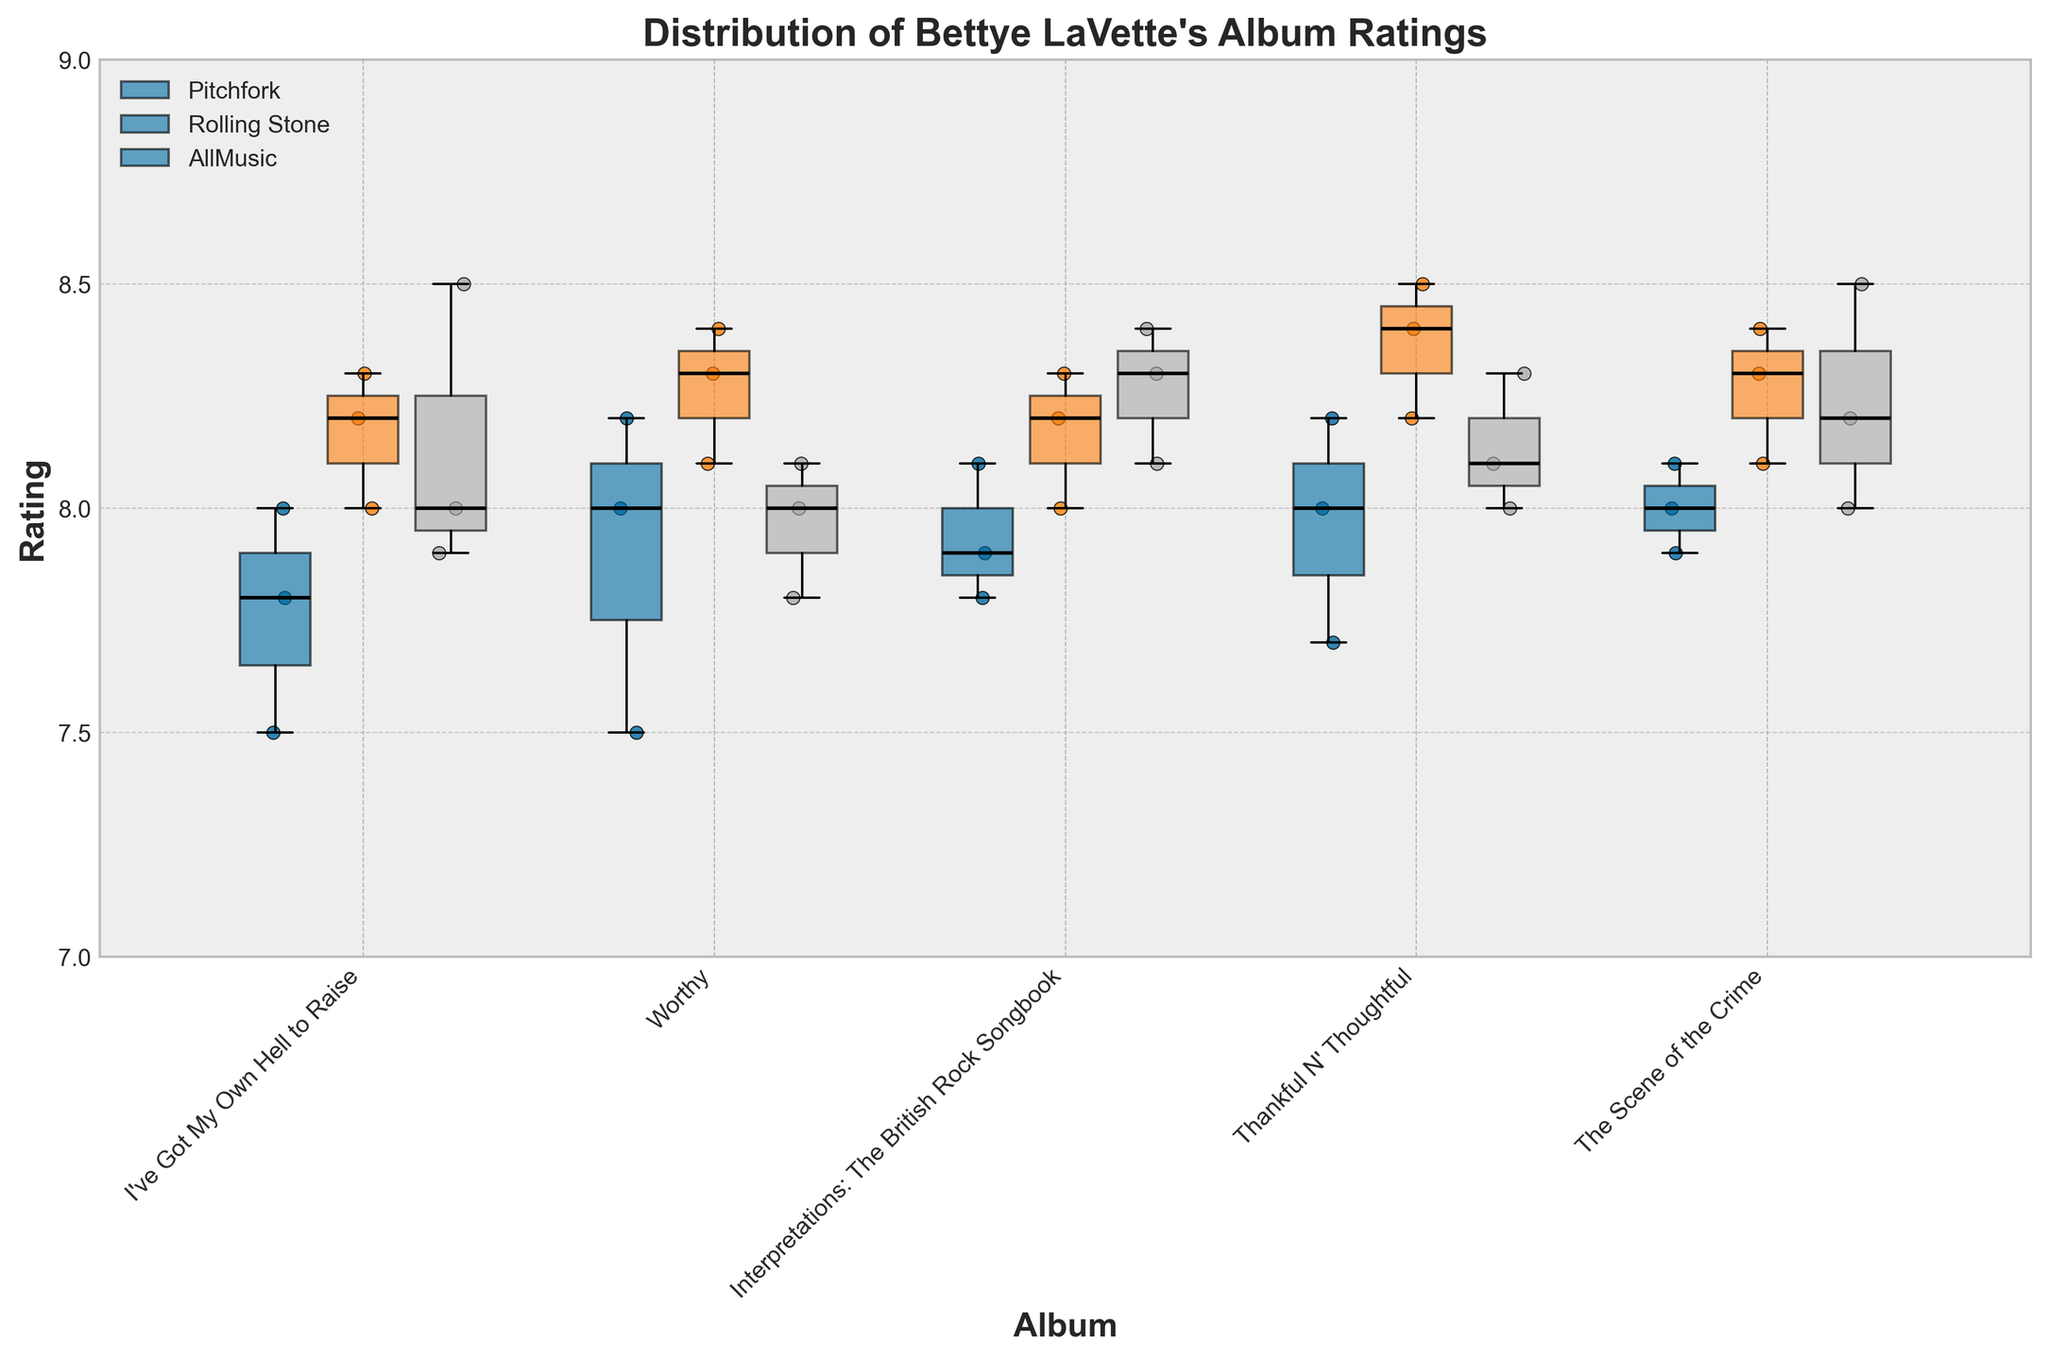What's the title of the figure? The title is displayed at the top of the figure.
Answer: Distribution of Bettye LaVette's Album Ratings Which album has the highest median rating on Rolling Stone? Look at the box plots for each album under the name "Rolling Stone" and identify which one has the highest median line (black line in the middle of the box).
Answer: Thankful N' Thoughtful How many albums are rated by Pitchfork? Count the number of unique titles on the x-axis under "Pitchfork".
Answer: 5 Which platform has the most consistent ratings for the album "The Scene of the Crime"? Check the box plots for "The Scene of the Crime" on each platform and identify the one with the smallest interquartile range (height of the box).
Answer: Pitchfork What is the range of ratings for "I've Got My Own Hell to Raise" on AllMusic? Look at the top and bottom whiskers of the AllMusic box plot for "I've Got My Own Hell to Raise" to determine the range.
Answer: 7.9 to 8.5 Which album's ratings have the highest variability on Pitchfork? Identify the album with the largest distance between the top and bottom whiskers on the Pitchfork box plots.
Answer: Thankful N' Thoughtful What is the median rating for "Worthy" on AllMusic? Find the middle line in the AllMusic box plot for "Worthy".
Answer: 8.0 Which album has the lowest median rating across all platforms? Identify the album that consistently has the lowest median lines across all platforms.
Answer: I've Got My Own Hell to Raise Are there any albums where all platforms have similar median ratings? Compare the median lines for each album across all three platforms to see if they align closely.
Answer: Yes, Worthy How does the variability in ratings for "Interpretations: The British Rock Songbook" on Pitchfork compare to that on Rolling Stone? Compare the interquartile ranges (the heights of the boxes) for "Interpretations: The British Rock Songbook" on Pitchfork and Rolling Stone.
Answer: Rolling Stone's variability is slightly less 